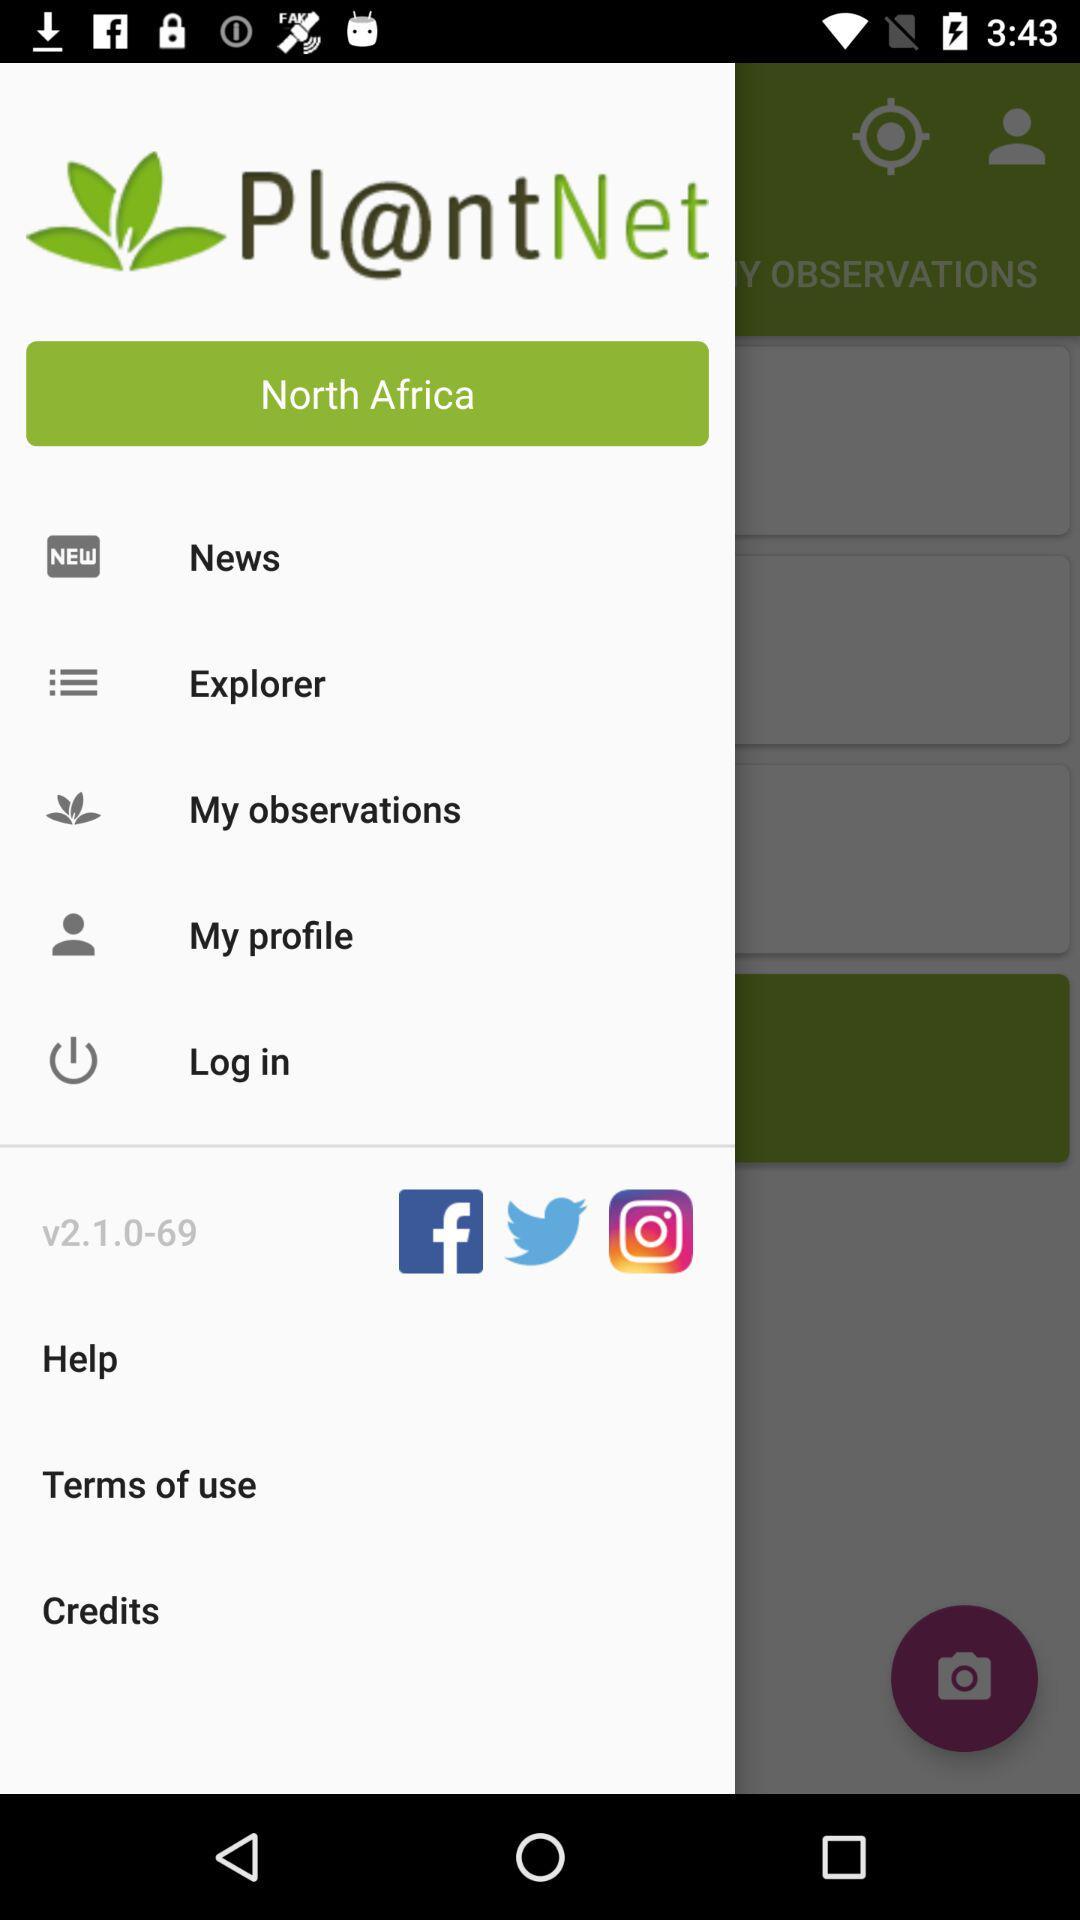What is the name of the application? The name of the application is "Pl@ntNet". 